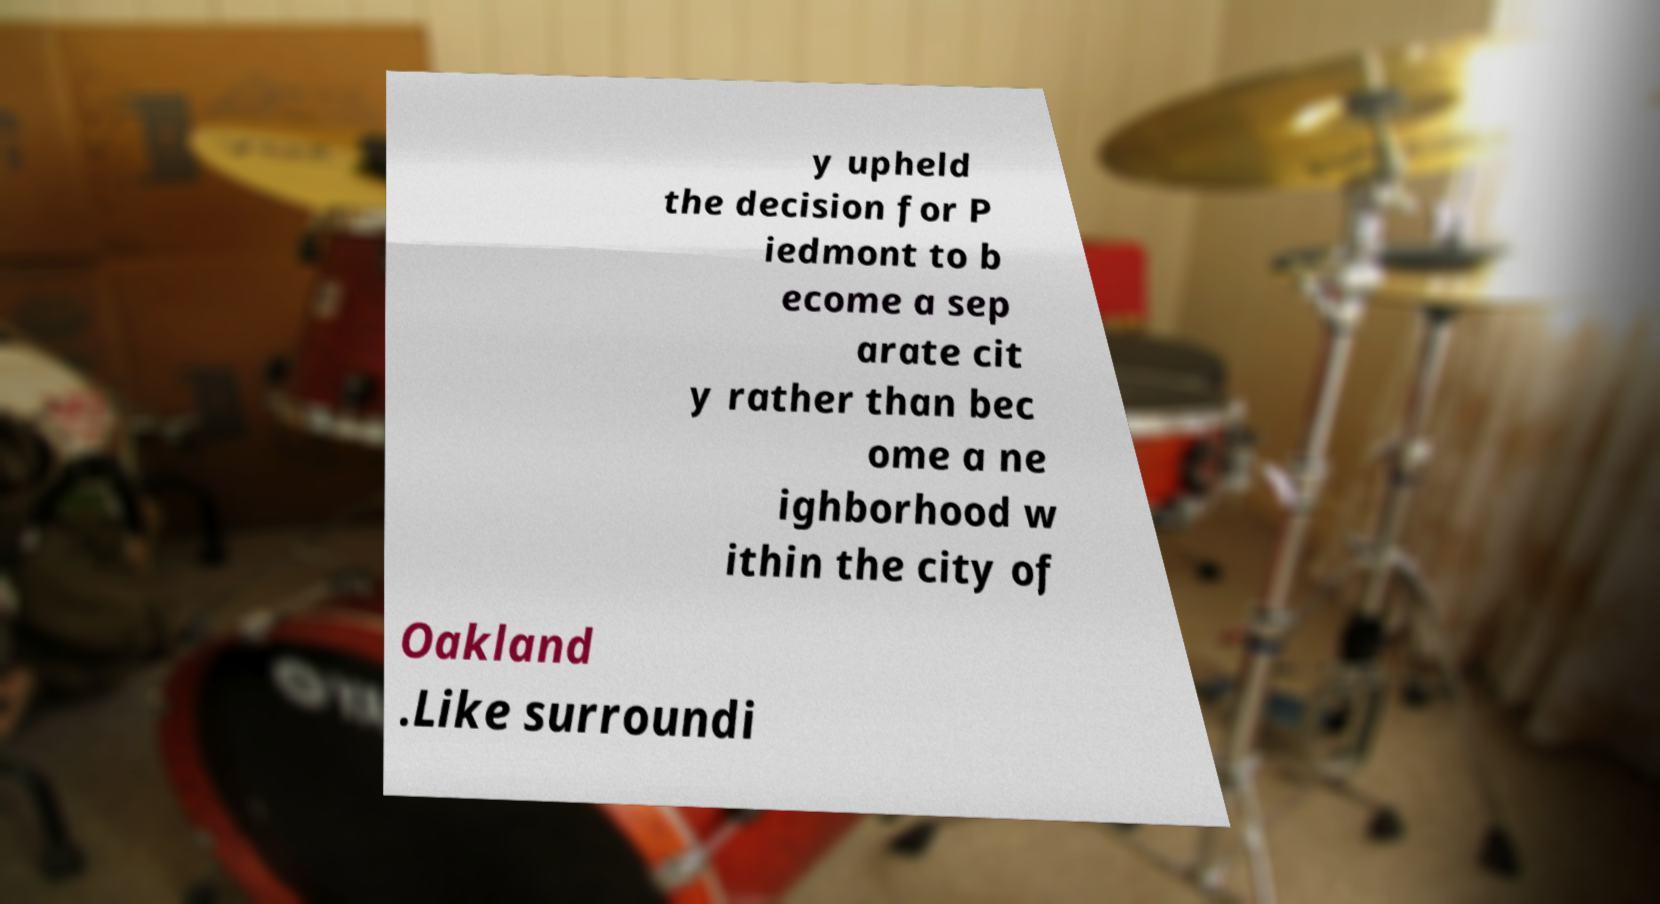Can you read and provide the text displayed in the image?This photo seems to have some interesting text. Can you extract and type it out for me? y upheld the decision for P iedmont to b ecome a sep arate cit y rather than bec ome a ne ighborhood w ithin the city of Oakland .Like surroundi 